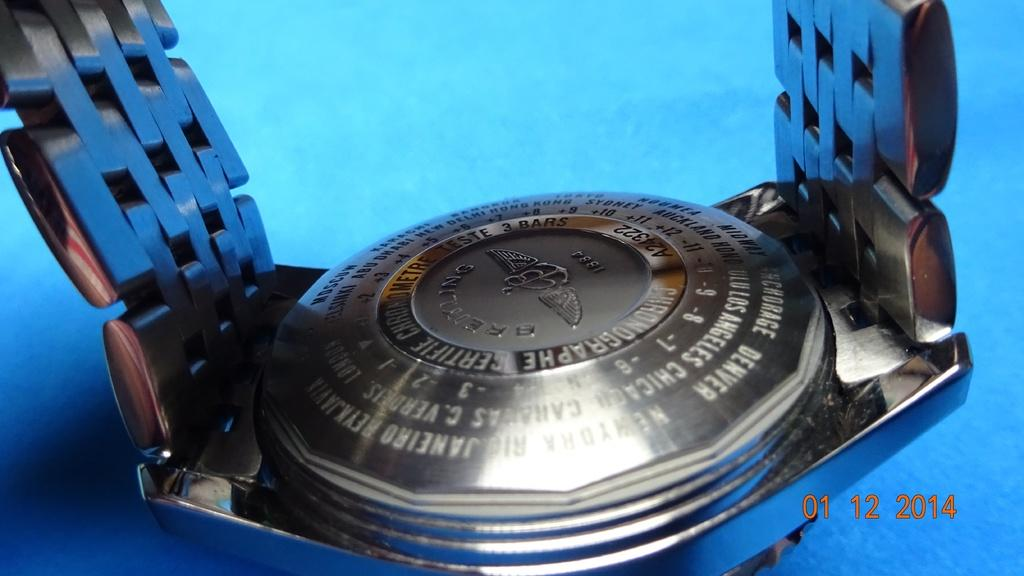<image>
Summarize the visual content of the image. A watch lies face down on a blue surface in a photo taken in 2014. 